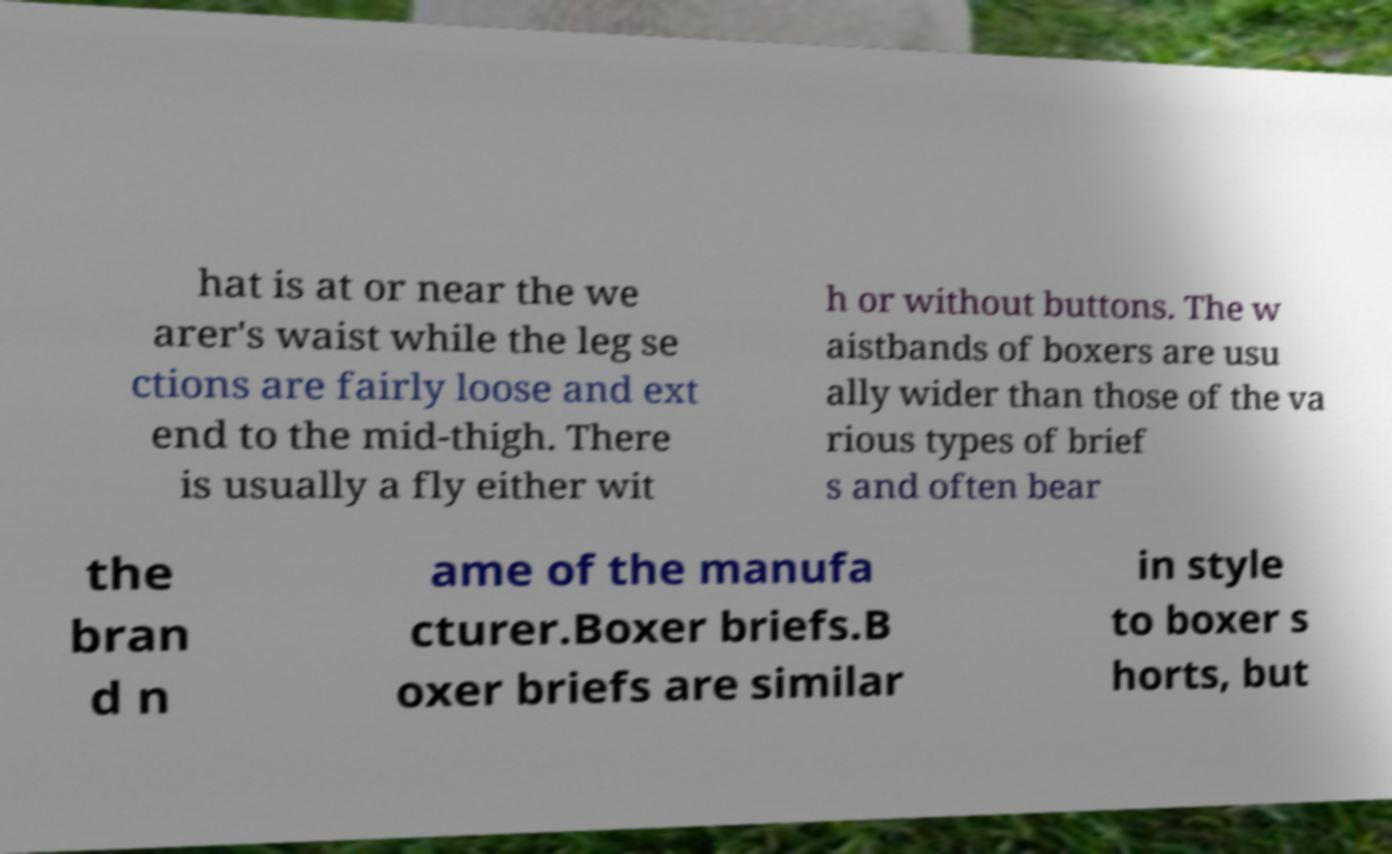I need the written content from this picture converted into text. Can you do that? hat is at or near the we arer's waist while the leg se ctions are fairly loose and ext end to the mid-thigh. There is usually a fly either wit h or without buttons. The w aistbands of boxers are usu ally wider than those of the va rious types of brief s and often bear the bran d n ame of the manufa cturer.Boxer briefs.B oxer briefs are similar in style to boxer s horts, but 